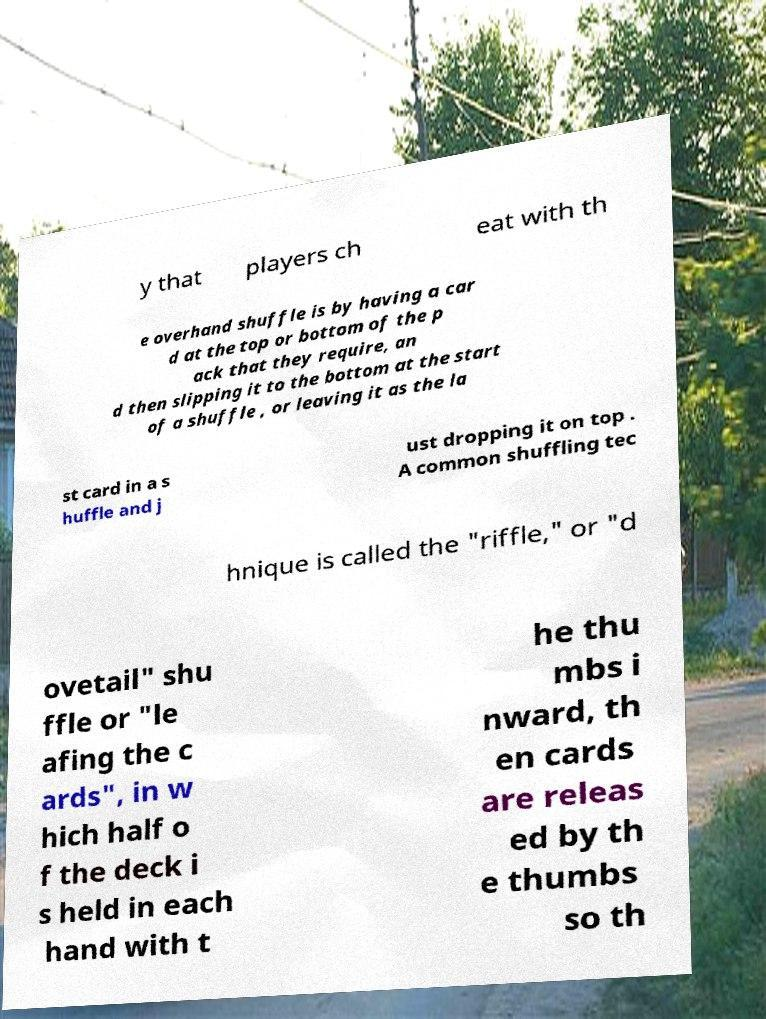Could you assist in decoding the text presented in this image and type it out clearly? y that players ch eat with th e overhand shuffle is by having a car d at the top or bottom of the p ack that they require, an d then slipping it to the bottom at the start of a shuffle , or leaving it as the la st card in a s huffle and j ust dropping it on top . A common shuffling tec hnique is called the "riffle," or "d ovetail" shu ffle or "le afing the c ards", in w hich half o f the deck i s held in each hand with t he thu mbs i nward, th en cards are releas ed by th e thumbs so th 